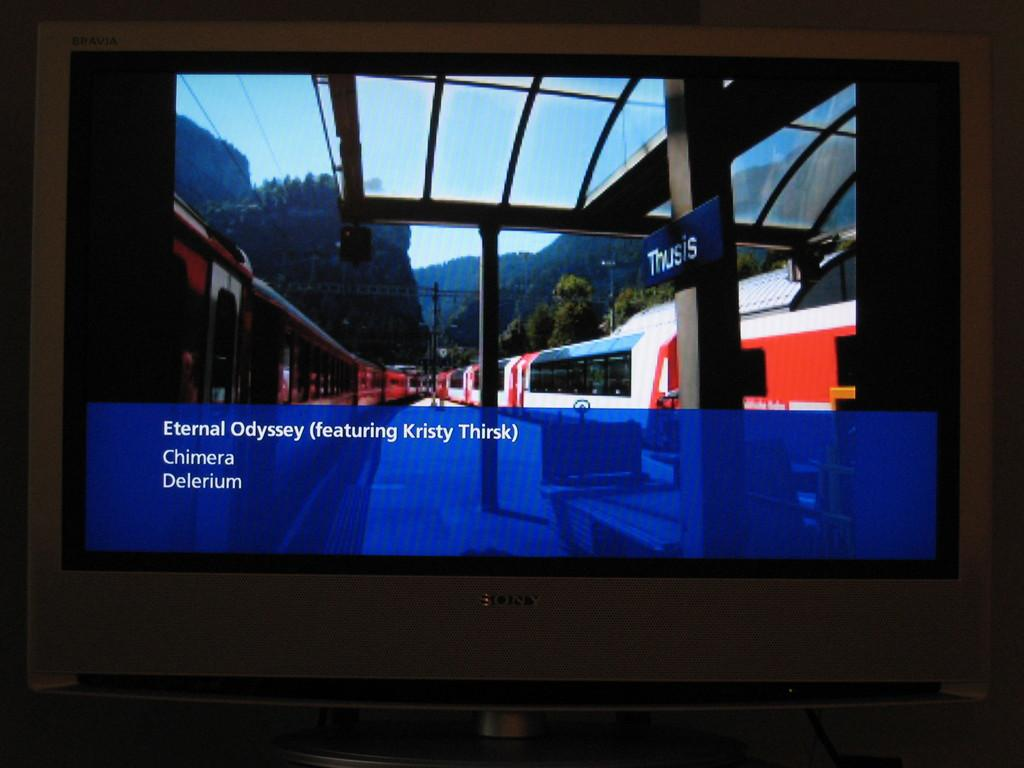<image>
Write a terse but informative summary of the picture. an eternal odyssey title that is on a blue heading on the screen 